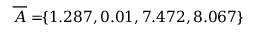<formula> <loc_0><loc_0><loc_500><loc_500>\, \overline { A } = \, \{ 1 . 2 8 7 , 0 . 0 1 , 7 . 4 7 2 , 8 . 0 6 7 \} \,</formula> 